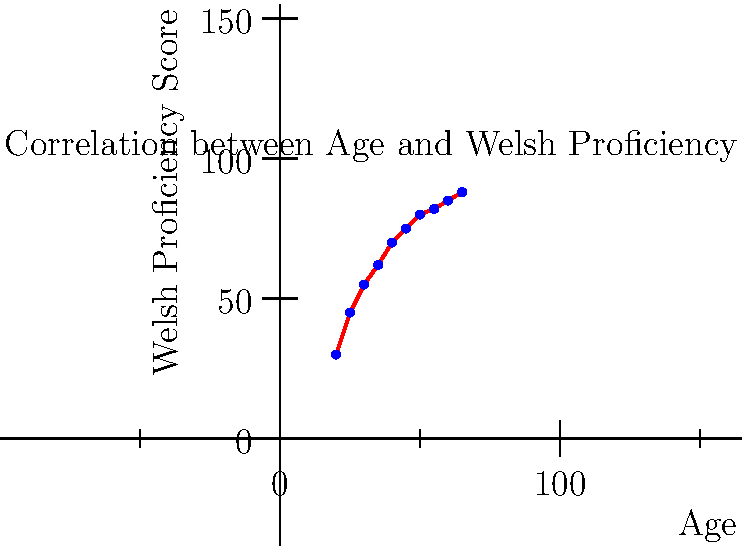Based on the scatter plot showing the correlation between age and Welsh language proficiency, what can be inferred about the relationship between these two variables? Additionally, calculate the Pearson correlation coefficient (r) to support your conclusion. To answer this question, we need to analyze the scatter plot and calculate the Pearson correlation coefficient:

1. Visual analysis of the scatter plot:
   - The points show a clear upward trend from left to right.
   - As age increases, Welsh proficiency scores generally increase.
   - The relationship appears to be positive and relatively strong.

2. Calculating the Pearson correlation coefficient (r):
   
   $r = \frac{\sum_{i=1}^{n} (x_i - \bar{x})(y_i - \bar{y})}{\sqrt{\sum_{i=1}^{n} (x_i - \bar{x})^2 \sum_{i=1}^{n} (y_i - \bar{y})^2}}$

   Where:
   $x_i$ = age values
   $y_i$ = proficiency scores
   $\bar{x}$ = mean of age values
   $\bar{y}$ = mean of proficiency scores

   Calculating the means:
   $\bar{x} = 42.5$
   $\bar{y} = 67.2$

   Calculating the numerator and denominator:
   $\sum_{i=1}^{n} (x_i - \bar{x})(y_i - \bar{y}) = 3318.75$
   $\sum_{i=1}^{n} (x_i - \bar{x})^2 = 2062.5$
   $\sum_{i=1}^{n} (y_i - \bar{y})^2 = 5647.6$

   $r = \frac{3318.75}{\sqrt{2062.5 \times 5647.6}} \approx 0.97$

3. Interpreting the results:
   - The Pearson correlation coefficient of 0.97 indicates a very strong positive correlation between age and Welsh language proficiency.
   - This supports the visual observation from the scatter plot.

Conclusion: There is a strong positive correlation between age and Welsh language proficiency, suggesting that older individuals tend to have higher proficiency scores in the Welsh language.
Answer: Strong positive correlation (r ≈ 0.97) between age and Welsh proficiency. 